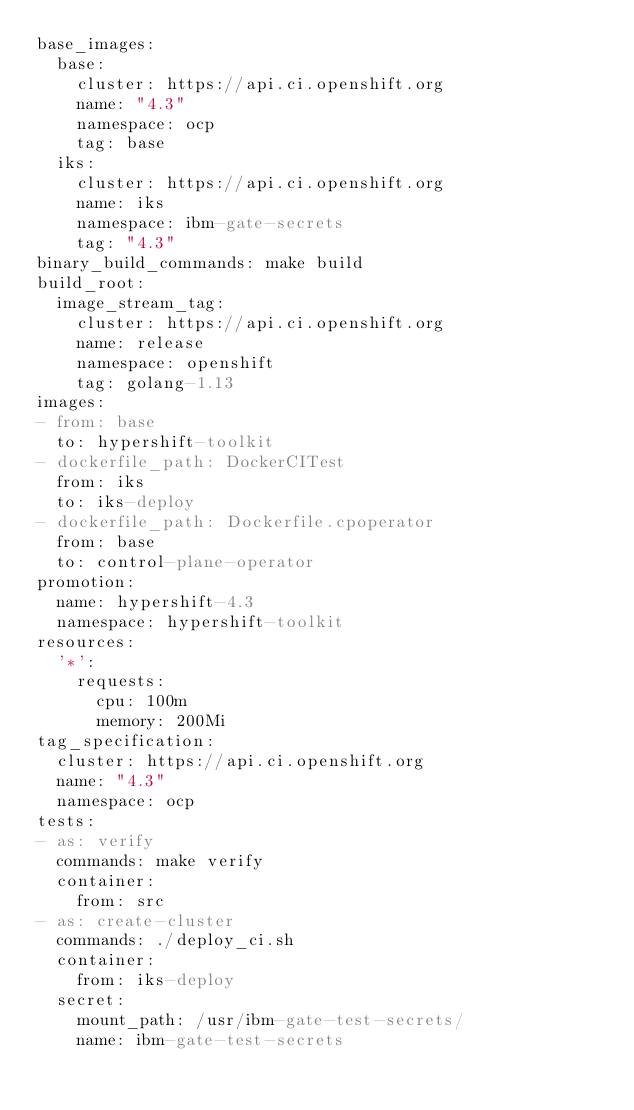<code> <loc_0><loc_0><loc_500><loc_500><_YAML_>base_images:
  base:
    cluster: https://api.ci.openshift.org
    name: "4.3"
    namespace: ocp
    tag: base
  iks:
    cluster: https://api.ci.openshift.org
    name: iks
    namespace: ibm-gate-secrets
    tag: "4.3"
binary_build_commands: make build
build_root:
  image_stream_tag:
    cluster: https://api.ci.openshift.org
    name: release
    namespace: openshift
    tag: golang-1.13
images:
- from: base
  to: hypershift-toolkit
- dockerfile_path: DockerCITest
  from: iks
  to: iks-deploy
- dockerfile_path: Dockerfile.cpoperator
  from: base
  to: control-plane-operator
promotion:
  name: hypershift-4.3
  namespace: hypershift-toolkit
resources:
  '*':
    requests:
      cpu: 100m
      memory: 200Mi
tag_specification:
  cluster: https://api.ci.openshift.org
  name: "4.3"
  namespace: ocp
tests:
- as: verify
  commands: make verify
  container:
    from: src
- as: create-cluster
  commands: ./deploy_ci.sh
  container:
    from: iks-deploy
  secret:
    mount_path: /usr/ibm-gate-test-secrets/
    name: ibm-gate-test-secrets
</code> 